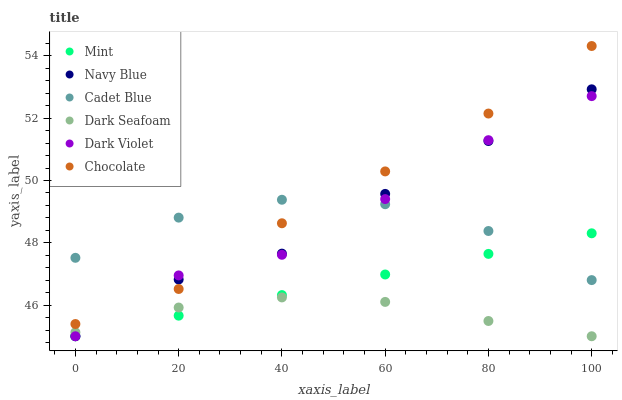Does Dark Seafoam have the minimum area under the curve?
Answer yes or no. Yes. Does Chocolate have the maximum area under the curve?
Answer yes or no. Yes. Does Navy Blue have the minimum area under the curve?
Answer yes or no. No. Does Navy Blue have the maximum area under the curve?
Answer yes or no. No. Is Mint the smoothest?
Answer yes or no. Yes. Is Dark Violet the roughest?
Answer yes or no. Yes. Is Navy Blue the smoothest?
Answer yes or no. No. Is Navy Blue the roughest?
Answer yes or no. No. Does Navy Blue have the lowest value?
Answer yes or no. Yes. Does Chocolate have the lowest value?
Answer yes or no. No. Does Chocolate have the highest value?
Answer yes or no. Yes. Does Navy Blue have the highest value?
Answer yes or no. No. Is Dark Seafoam less than Chocolate?
Answer yes or no. Yes. Is Cadet Blue greater than Dark Seafoam?
Answer yes or no. Yes. Does Cadet Blue intersect Chocolate?
Answer yes or no. Yes. Is Cadet Blue less than Chocolate?
Answer yes or no. No. Is Cadet Blue greater than Chocolate?
Answer yes or no. No. Does Dark Seafoam intersect Chocolate?
Answer yes or no. No. 